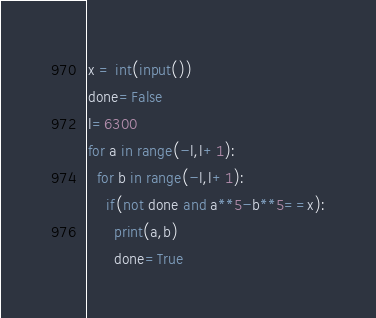Convert code to text. <code><loc_0><loc_0><loc_500><loc_500><_Python_>x = int(input())
done=False
l=6300
for a in range(-l,l+1):
  for b in range(-l,l+1):
    if(not done and a**5-b**5==x):
      print(a,b)
      done=True</code> 